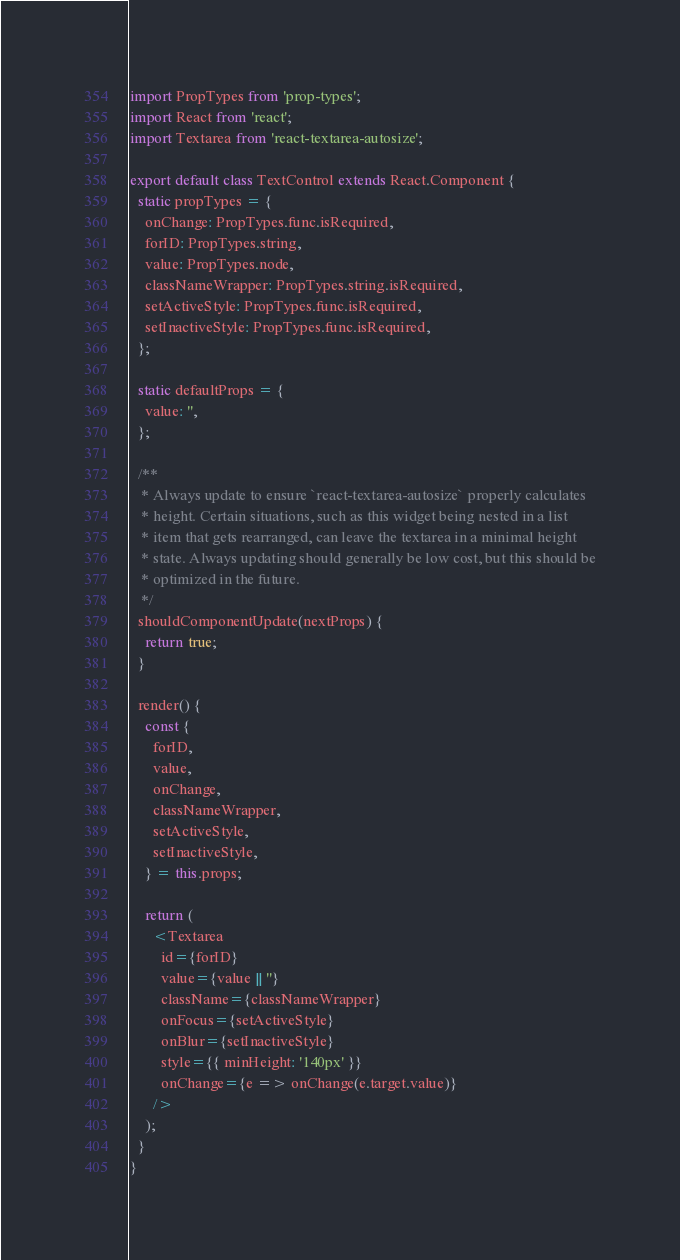<code> <loc_0><loc_0><loc_500><loc_500><_JavaScript_>import PropTypes from 'prop-types';
import React from 'react';
import Textarea from 'react-textarea-autosize';

export default class TextControl extends React.Component {
  static propTypes = {
    onChange: PropTypes.func.isRequired,
    forID: PropTypes.string,
    value: PropTypes.node,
    classNameWrapper: PropTypes.string.isRequired,
    setActiveStyle: PropTypes.func.isRequired,
    setInactiveStyle: PropTypes.func.isRequired,
  };

  static defaultProps = {
    value: '',
  };

  /**
   * Always update to ensure `react-textarea-autosize` properly calculates
   * height. Certain situations, such as this widget being nested in a list
   * item that gets rearranged, can leave the textarea in a minimal height
   * state. Always updating should generally be low cost, but this should be
   * optimized in the future.
   */
  shouldComponentUpdate(nextProps) {
    return true;
  }

  render() {
    const {
      forID,
      value,
      onChange,
      classNameWrapper,
      setActiveStyle,
      setInactiveStyle,
    } = this.props;

    return (
      <Textarea
        id={forID}
        value={value || ''}
        className={classNameWrapper}
        onFocus={setActiveStyle}
        onBlur={setInactiveStyle}
        style={{ minHeight: '140px' }}
        onChange={e => onChange(e.target.value)}
      />
    );
  }
}
</code> 